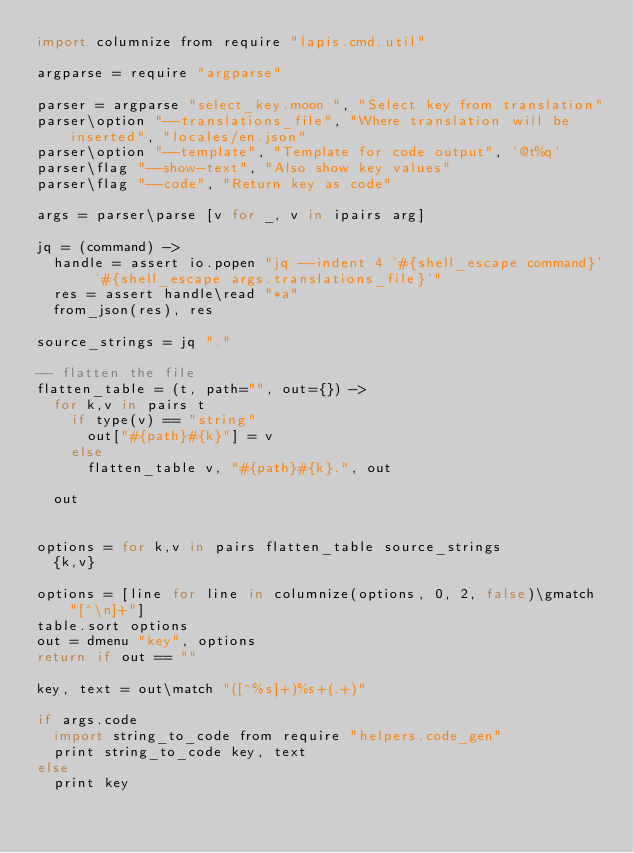<code> <loc_0><loc_0><loc_500><loc_500><_MoonScript_>import columnize from require "lapis.cmd.util"

argparse = require "argparse"

parser = argparse "select_key.moon ", "Select key from translation"
parser\option "--translations_file", "Where translation will be inserted", "locales/en.json"
parser\option "--template", "Template for code output", '@t%q'
parser\flag "--show-text", "Also show key values"
parser\flag "--code", "Return key as code"

args = parser\parse [v for _, v in ipairs arg]

jq = (command) ->
  handle = assert io.popen "jq --indent 4 '#{shell_escape command}' '#{shell_escape args.translations_file}'"
  res = assert handle\read "*a"
  from_json(res), res

source_strings = jq "."

-- flatten the file
flatten_table = (t, path="", out={}) ->
  for k,v in pairs t
    if type(v) == "string"
      out["#{path}#{k}"] = v
    else
      flatten_table v, "#{path}#{k}.", out

  out


options = for k,v in pairs flatten_table source_strings
  {k,v}

options = [line for line in columnize(options, 0, 2, false)\gmatch "[^\n]+"]
table.sort options
out = dmenu "key", options
return if out == ""

key, text = out\match "([^%s]+)%s+(.+)"

if args.code
  import string_to_code from require "helpers.code_gen"
  print string_to_code key, text
else
  print key


</code> 